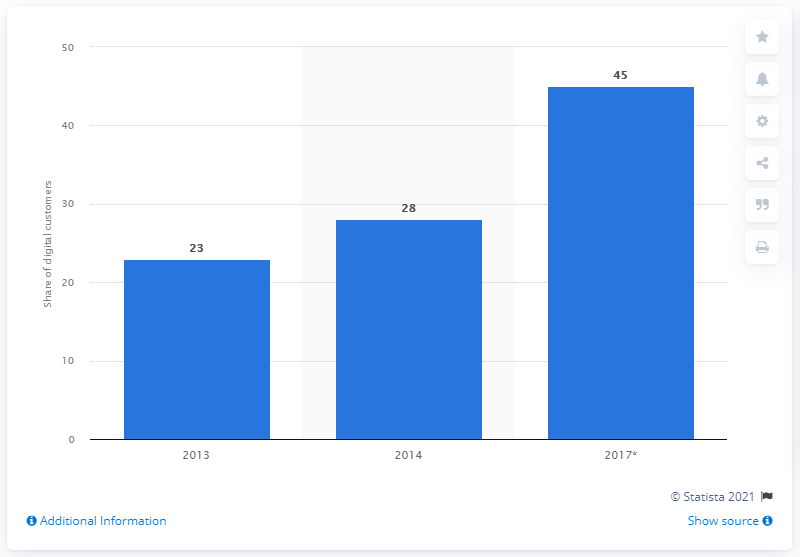Outline some significant characteristics in this image. In 2013, 23% of Santander customers used digital channels to access their banking services. In 2014, 28% of Santander customers used digital channels to access banking services. Santander aimed to reach 45% of its target customers by the end of 2017. 